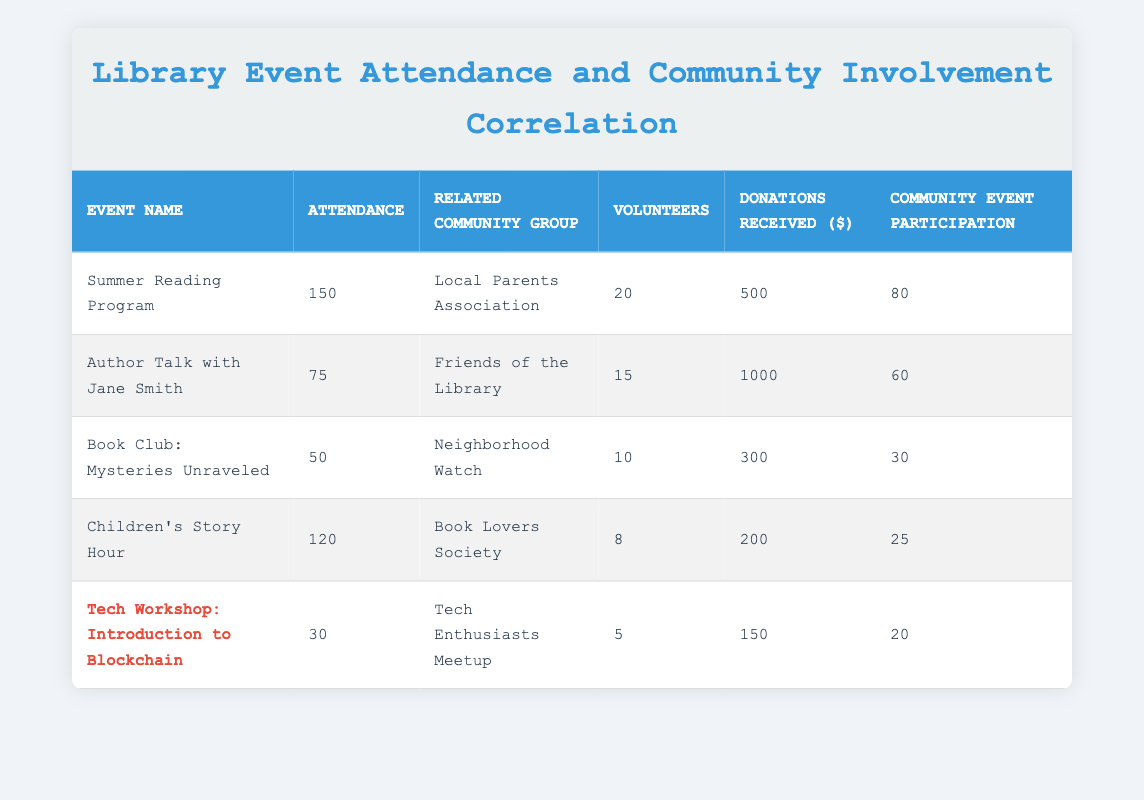What is the attendance for the "Children's Story Hour"? The table lists the attendance for each event directly. For "Children's Story Hour," the attendance is shown as 120.
Answer: 120 Which community group has the highest donations received? By looking at the donations received column, the highest value is found in the row for "Friends of the Library," which is 1000.
Answer: Friends of the Library What is the average attendance across all events? To find the average attendance, sum all attendance numbers: 150 + 75 + 50 + 120 + 30 = 425. There are 5 events, so the average attendance is 425/5 = 85.
Answer: 85 Is there a community group associated with the "Tech Workshop: Introduction to Blockchain"? Yes, the table shows that the community group associated with the "Tech Workshop: Introduction to Blockchain" is "Tech Enthusiasts Meetup."
Answer: Yes Which event had the lowest attendance, and what was it? By reviewing the attendance numbers, the lowest figure is 30, which corresponds to the "Tech Workshop: Introduction to Blockchain."
Answer: Tech Workshop: Introduction to Blockchain, 30 What is the total number of volunteers associated with all events? To find the total number of volunteers, sum the volunteers from each community group: 20 + 15 + 10 + 8 + 5 = 58.
Answer: 58 Does the "Neighborhood Watch" group have more volunteers than the "Tech Enthusiasts Meetup"? Yes, "Neighborhood Watch" has 10 volunteers, while "Tech Enthusiasts Meetup" has only 5.
Answer: Yes What is the difference in community event participation between "Summer Reading Program" and "Children's Story Hour"? For "Summer Reading Program," community event participation is 80; for "Children's Story Hour," it is 25. The difference is calculated as 80 - 25 = 55.
Answer: 55 How many community events did the group "Book Lovers Society" participate in? The participation for "Book Lovers Society" is shown as 25 directly in the table.
Answer: 25 